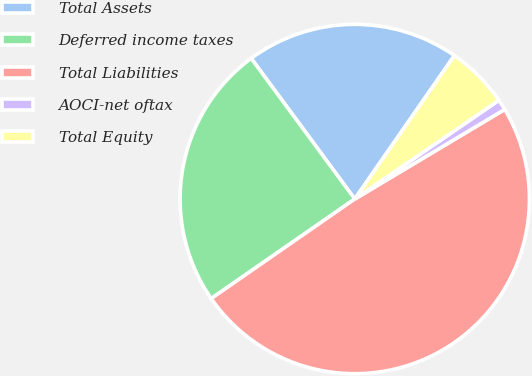Convert chart to OTSL. <chart><loc_0><loc_0><loc_500><loc_500><pie_chart><fcel>Total Assets<fcel>Deferred income taxes<fcel>Total Liabilities<fcel>AOCI-net oftax<fcel>Total Equity<nl><fcel>19.76%<fcel>24.55%<fcel>48.92%<fcel>0.99%<fcel>5.78%<nl></chart> 